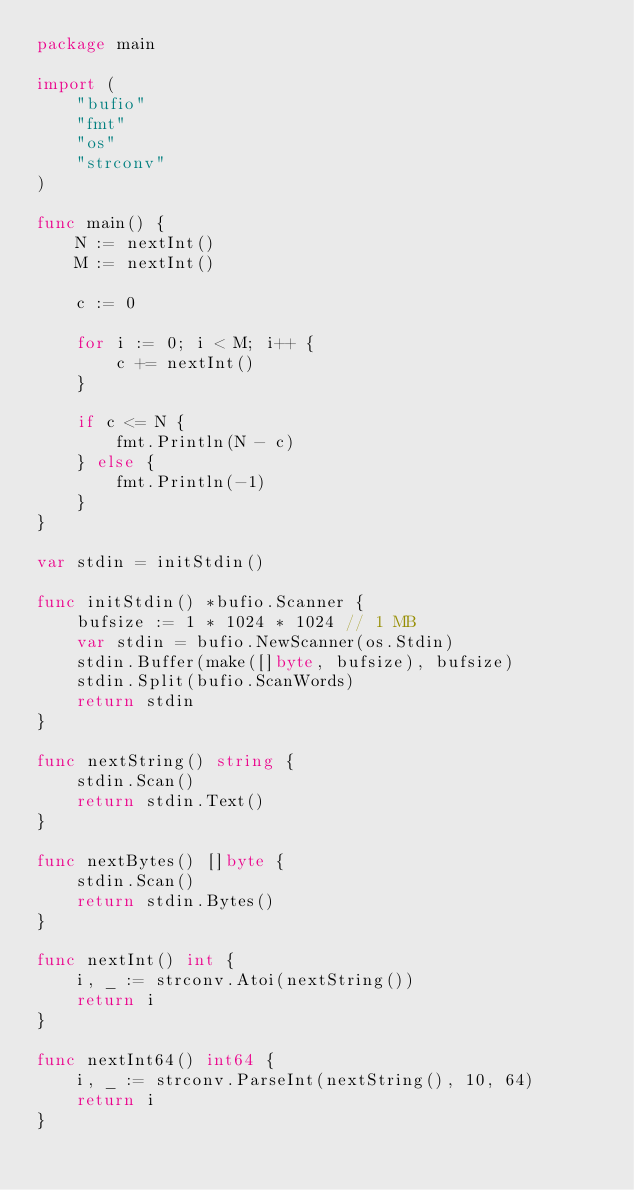<code> <loc_0><loc_0><loc_500><loc_500><_Go_>package main

import (
	"bufio"
	"fmt"
	"os"
	"strconv"
)

func main() {
	N := nextInt()
	M := nextInt()

	c := 0

	for i := 0; i < M; i++ {
		c += nextInt()
	}

	if c <= N {
		fmt.Println(N - c)
	} else {
		fmt.Println(-1)
	}
}

var stdin = initStdin()

func initStdin() *bufio.Scanner {
	bufsize := 1 * 1024 * 1024 // 1 MB
	var stdin = bufio.NewScanner(os.Stdin)
	stdin.Buffer(make([]byte, bufsize), bufsize)
	stdin.Split(bufio.ScanWords)
	return stdin
}

func nextString() string {
	stdin.Scan()
	return stdin.Text()
}

func nextBytes() []byte {
	stdin.Scan()
	return stdin.Bytes()
}

func nextInt() int {
	i, _ := strconv.Atoi(nextString())
	return i
}

func nextInt64() int64 {
	i, _ := strconv.ParseInt(nextString(), 10, 64)
	return i
}
</code> 